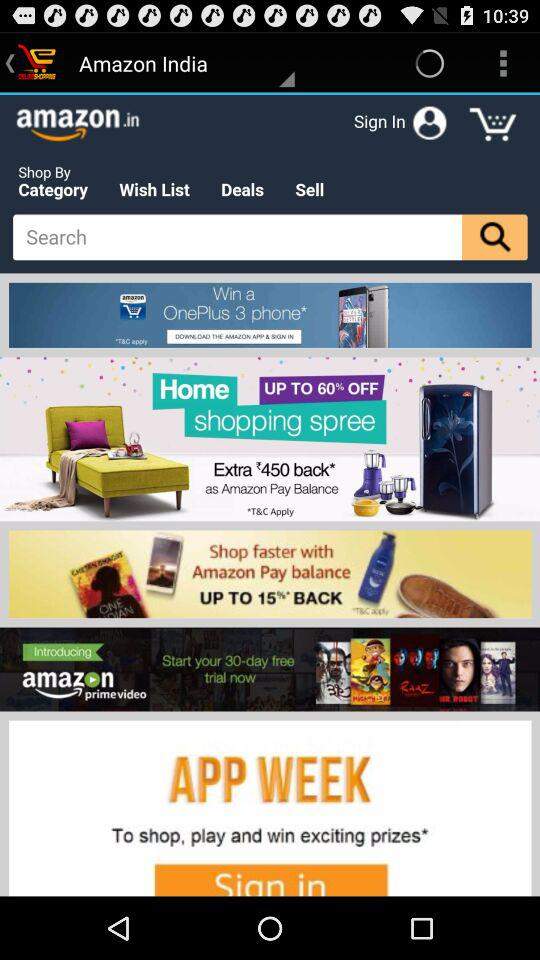What is the cashback percentage if I pay through Amazon Pay balance? The cashback percentage is 15. 